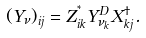<formula> <loc_0><loc_0><loc_500><loc_500>( Y _ { \nu } ) _ { i j } = Z _ { i k } ^ { ^ { * } } { Y } ^ { D } _ { \nu _ { k } } X _ { k j } ^ { \dagger } .</formula> 